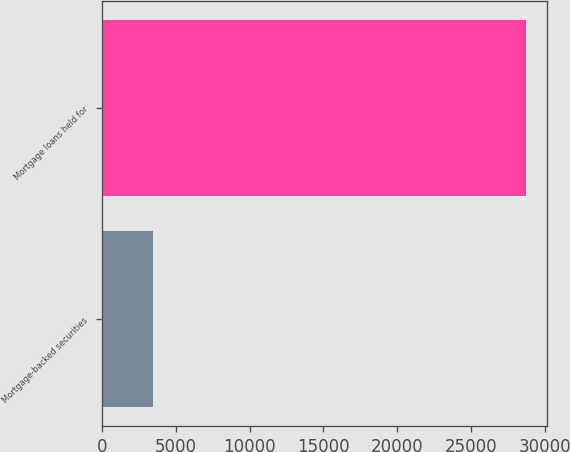Convert chart. <chart><loc_0><loc_0><loc_500><loc_500><bar_chart><fcel>Mortgage-backed securities<fcel>Mortgage loans held for<nl><fcel>3450<fcel>28689<nl></chart> 